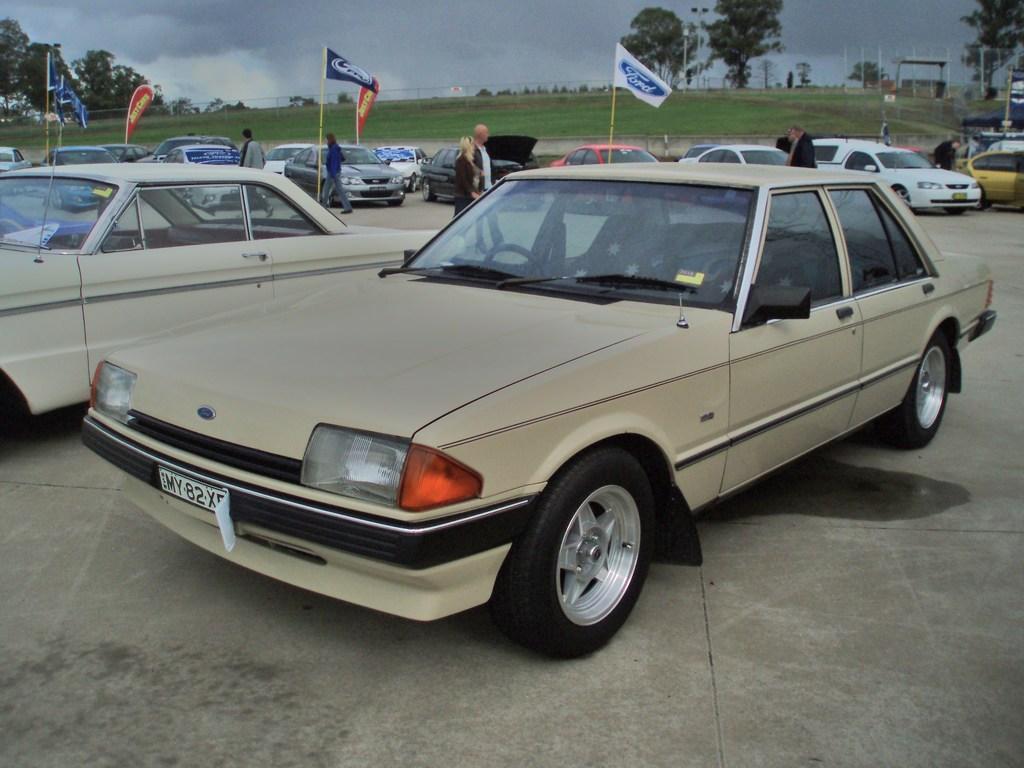How would you summarize this image in a sentence or two? In this picture I can see many cars which are parked on the parking. Beside that I can see some people are walking. On the left I can see many grass. in the background I can see the grass, open land, trees, plants, poles and street lights. At the top I can see the sky and clouds. 